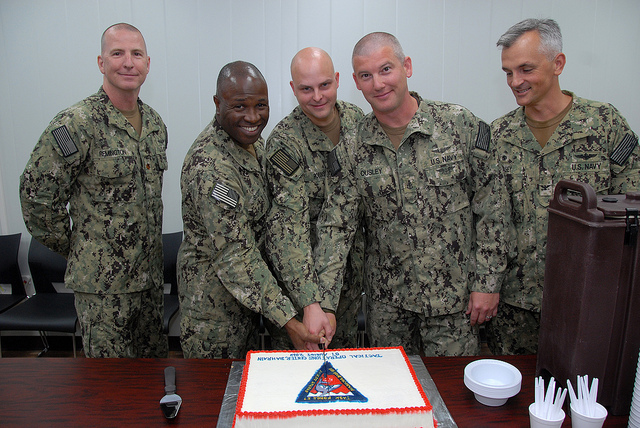Read all the text in this image. OUSLEY U.S. NAVY U.S. NAVY 